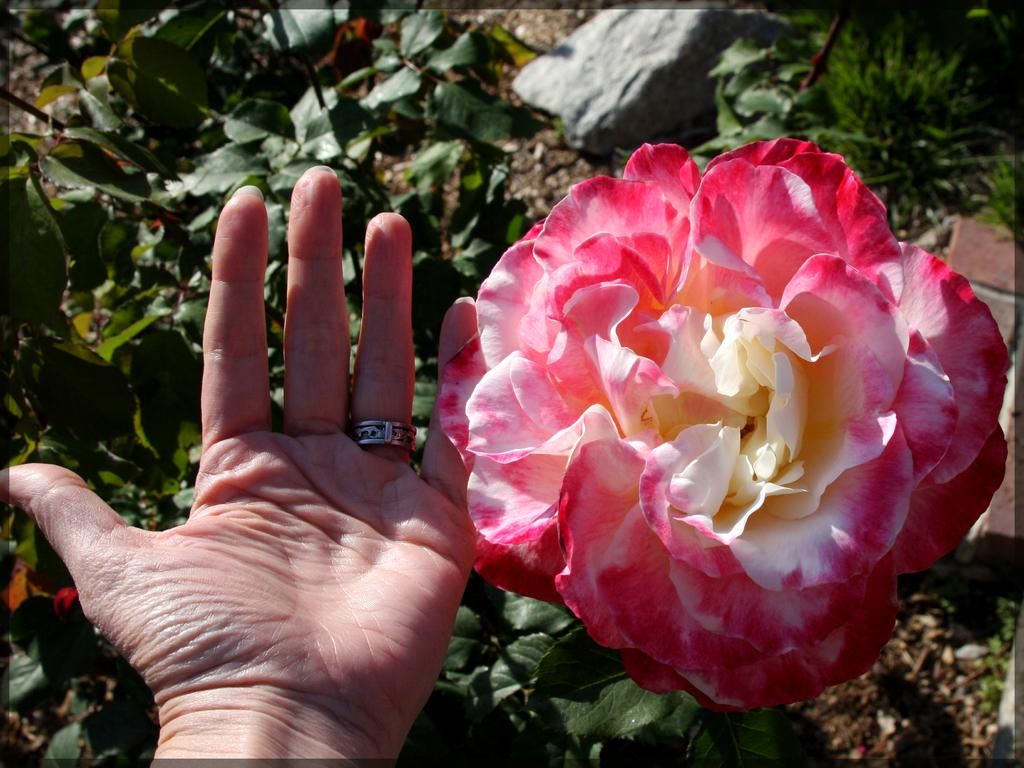What part of a person can be seen in the image? There is a person's hand in the image. What is the main object in the front of the image? There is a flower in the front of the image. What type of vegetation can be seen in the background of the image? There are plants in the background of the image. What other object can be seen in the background of the image? There is a stone in the background of the image. What type of holiday is being celebrated in the image? There is no indication of a holiday being celebrated in the image. What is the taste of the flower in the image? Flowers do not have a taste, so this question cannot be answered. 